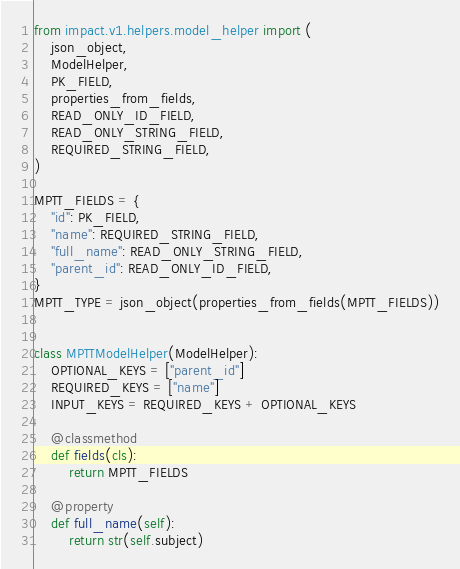Convert code to text. <code><loc_0><loc_0><loc_500><loc_500><_Python_>from impact.v1.helpers.model_helper import (
    json_object,
    ModelHelper,
    PK_FIELD,
    properties_from_fields,
    READ_ONLY_ID_FIELD,
    READ_ONLY_STRING_FIELD,
    REQUIRED_STRING_FIELD,
)

MPTT_FIELDS = {
    "id": PK_FIELD,
    "name": REQUIRED_STRING_FIELD,
    "full_name": READ_ONLY_STRING_FIELD,
    "parent_id": READ_ONLY_ID_FIELD,
}
MPTT_TYPE = json_object(properties_from_fields(MPTT_FIELDS))


class MPTTModelHelper(ModelHelper):
    OPTIONAL_KEYS = ["parent_id"]
    REQUIRED_KEYS = ["name"]
    INPUT_KEYS = REQUIRED_KEYS + OPTIONAL_KEYS

    @classmethod
    def fields(cls):
        return MPTT_FIELDS

    @property
    def full_name(self):
        return str(self.subject)
</code> 